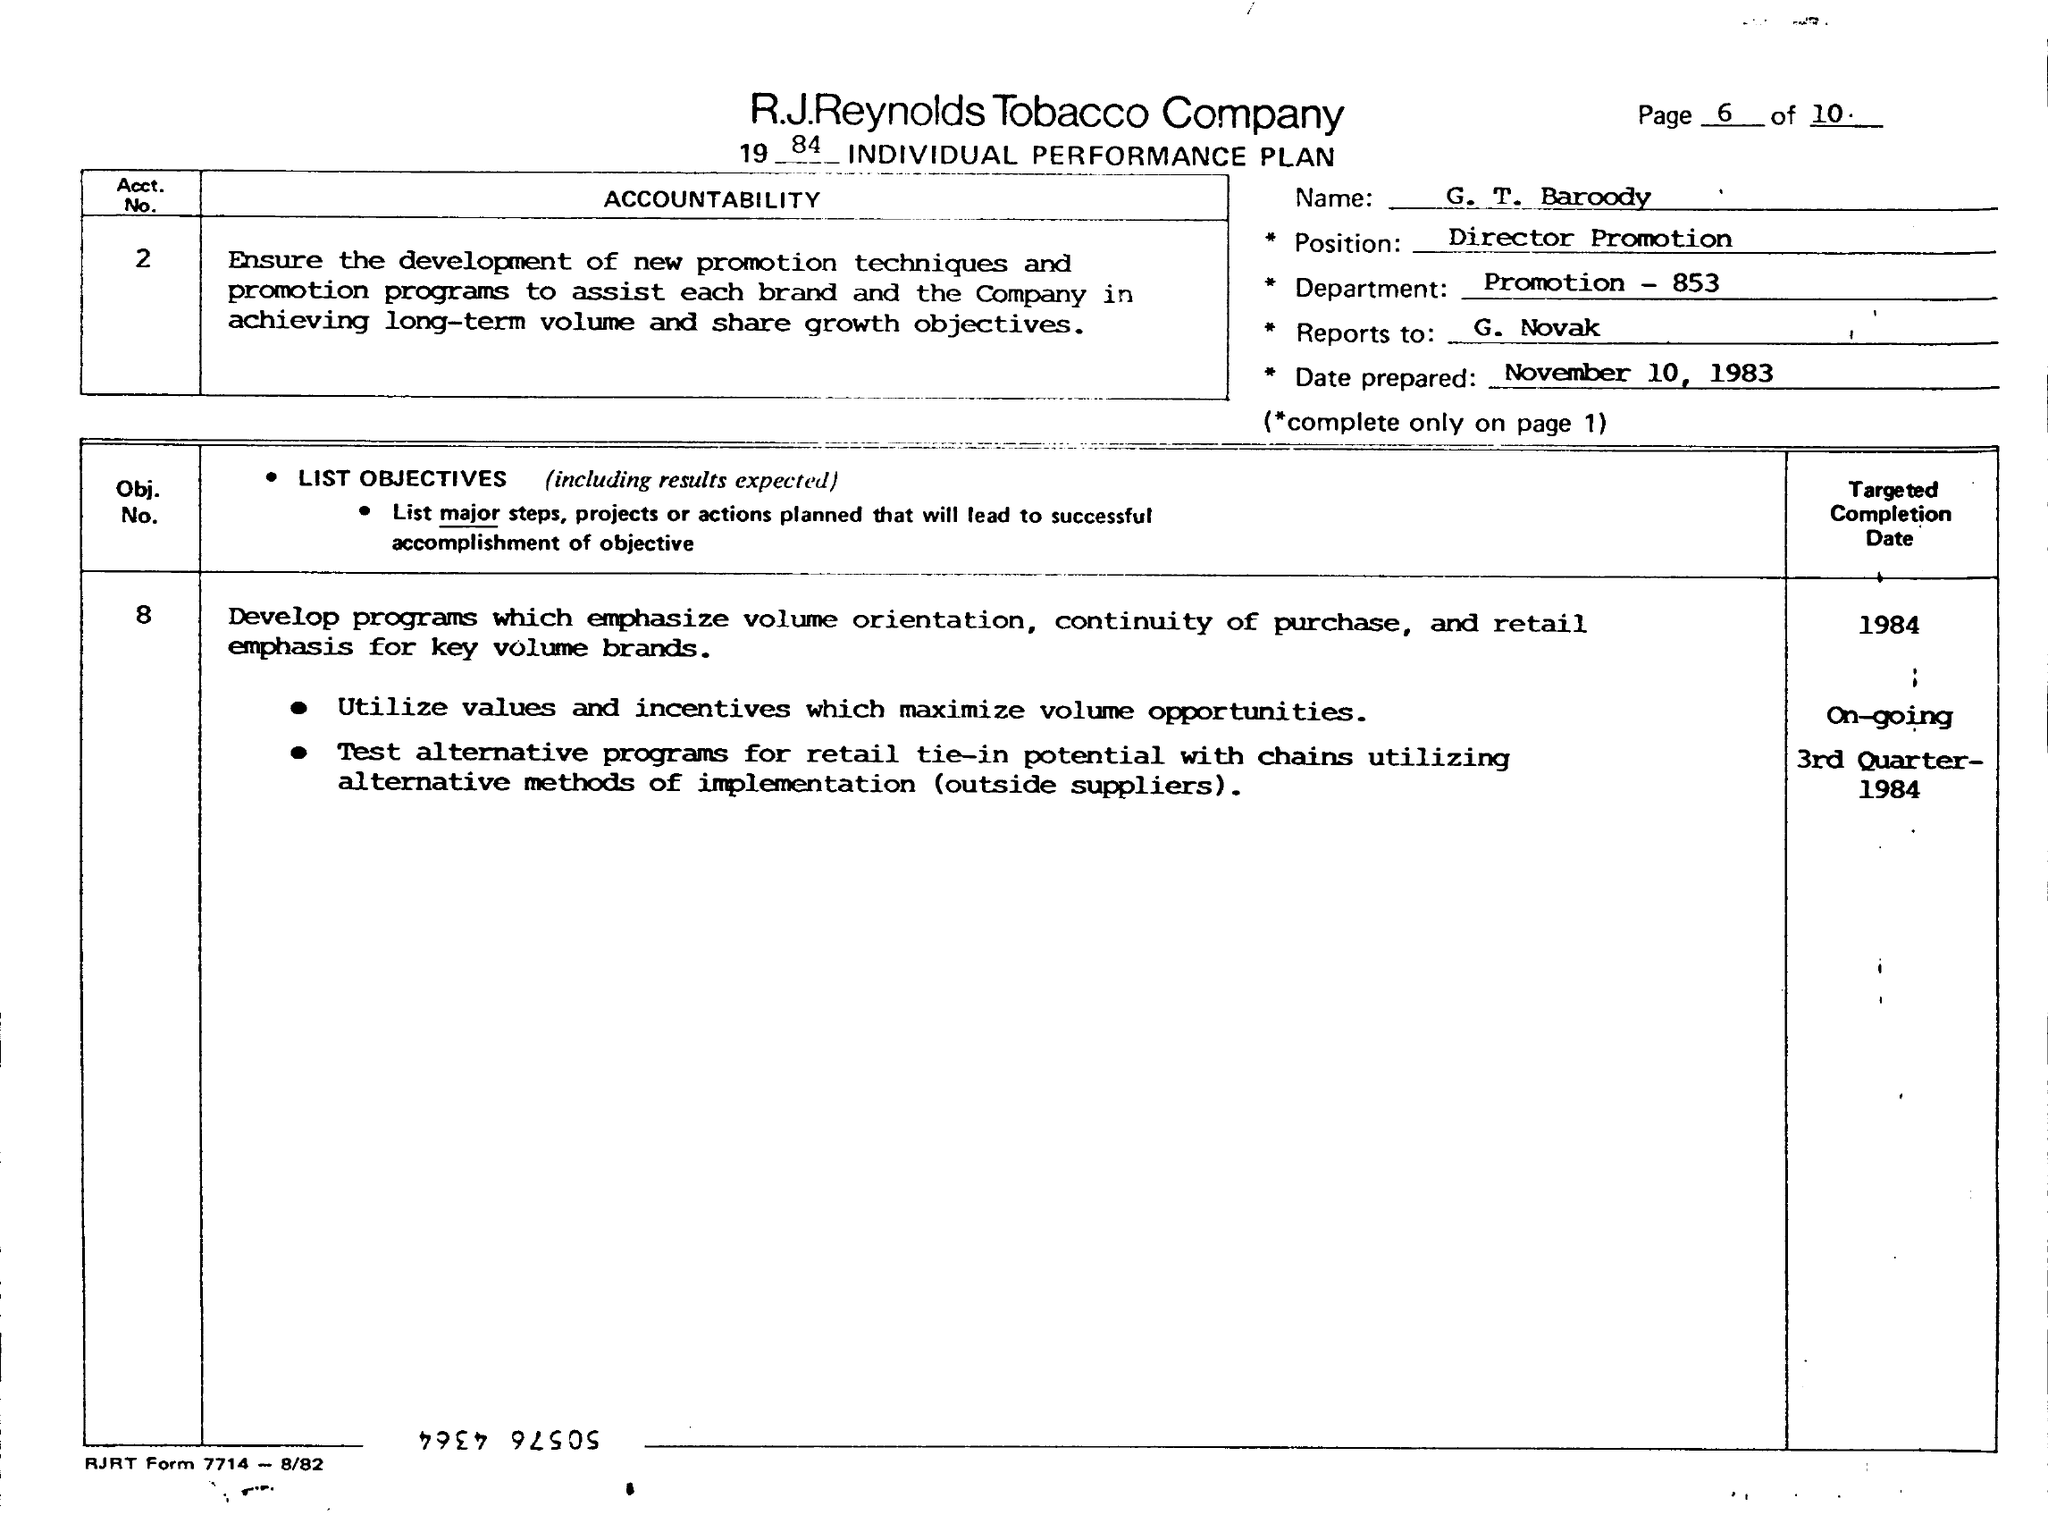What is the position of G T Barody?
Offer a terse response. Director promotion. What is the Prepared date
Your answer should be very brief. November 10, 1983. 